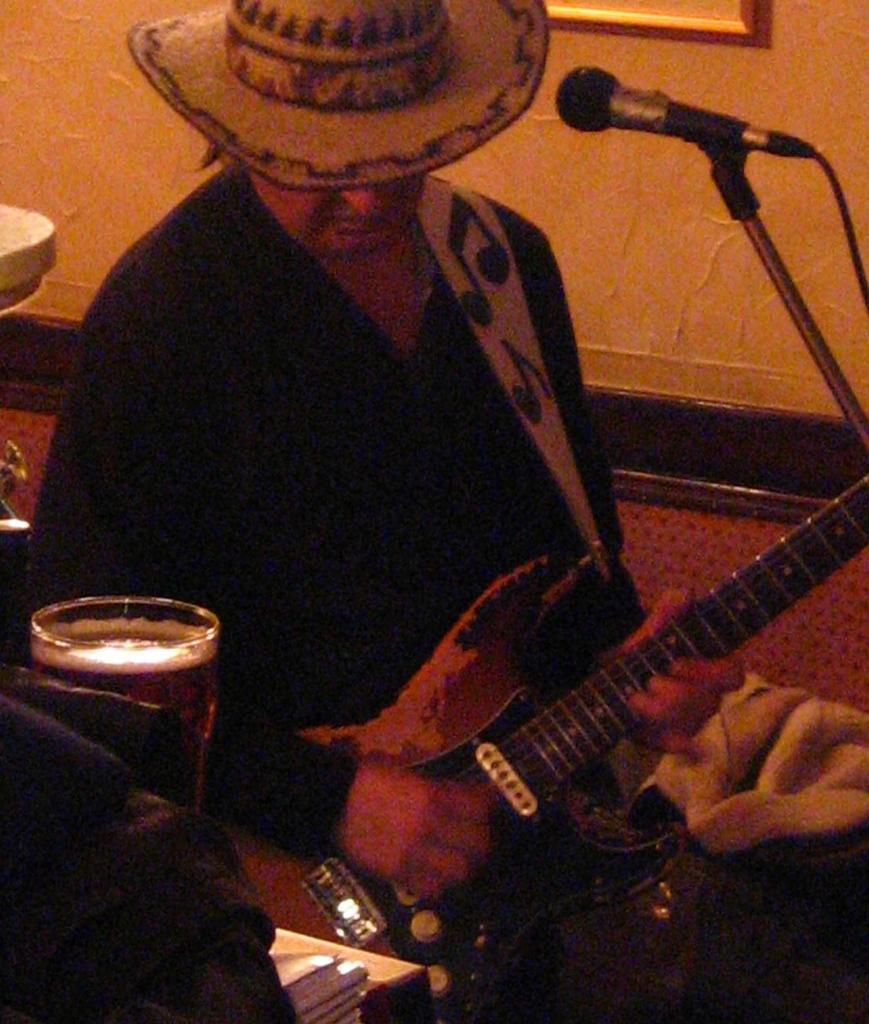How would you summarize this image in a sentence or two? In this image I can see a person is holding a guitar and wearing a hat. Here I can see a mic and a glass. 